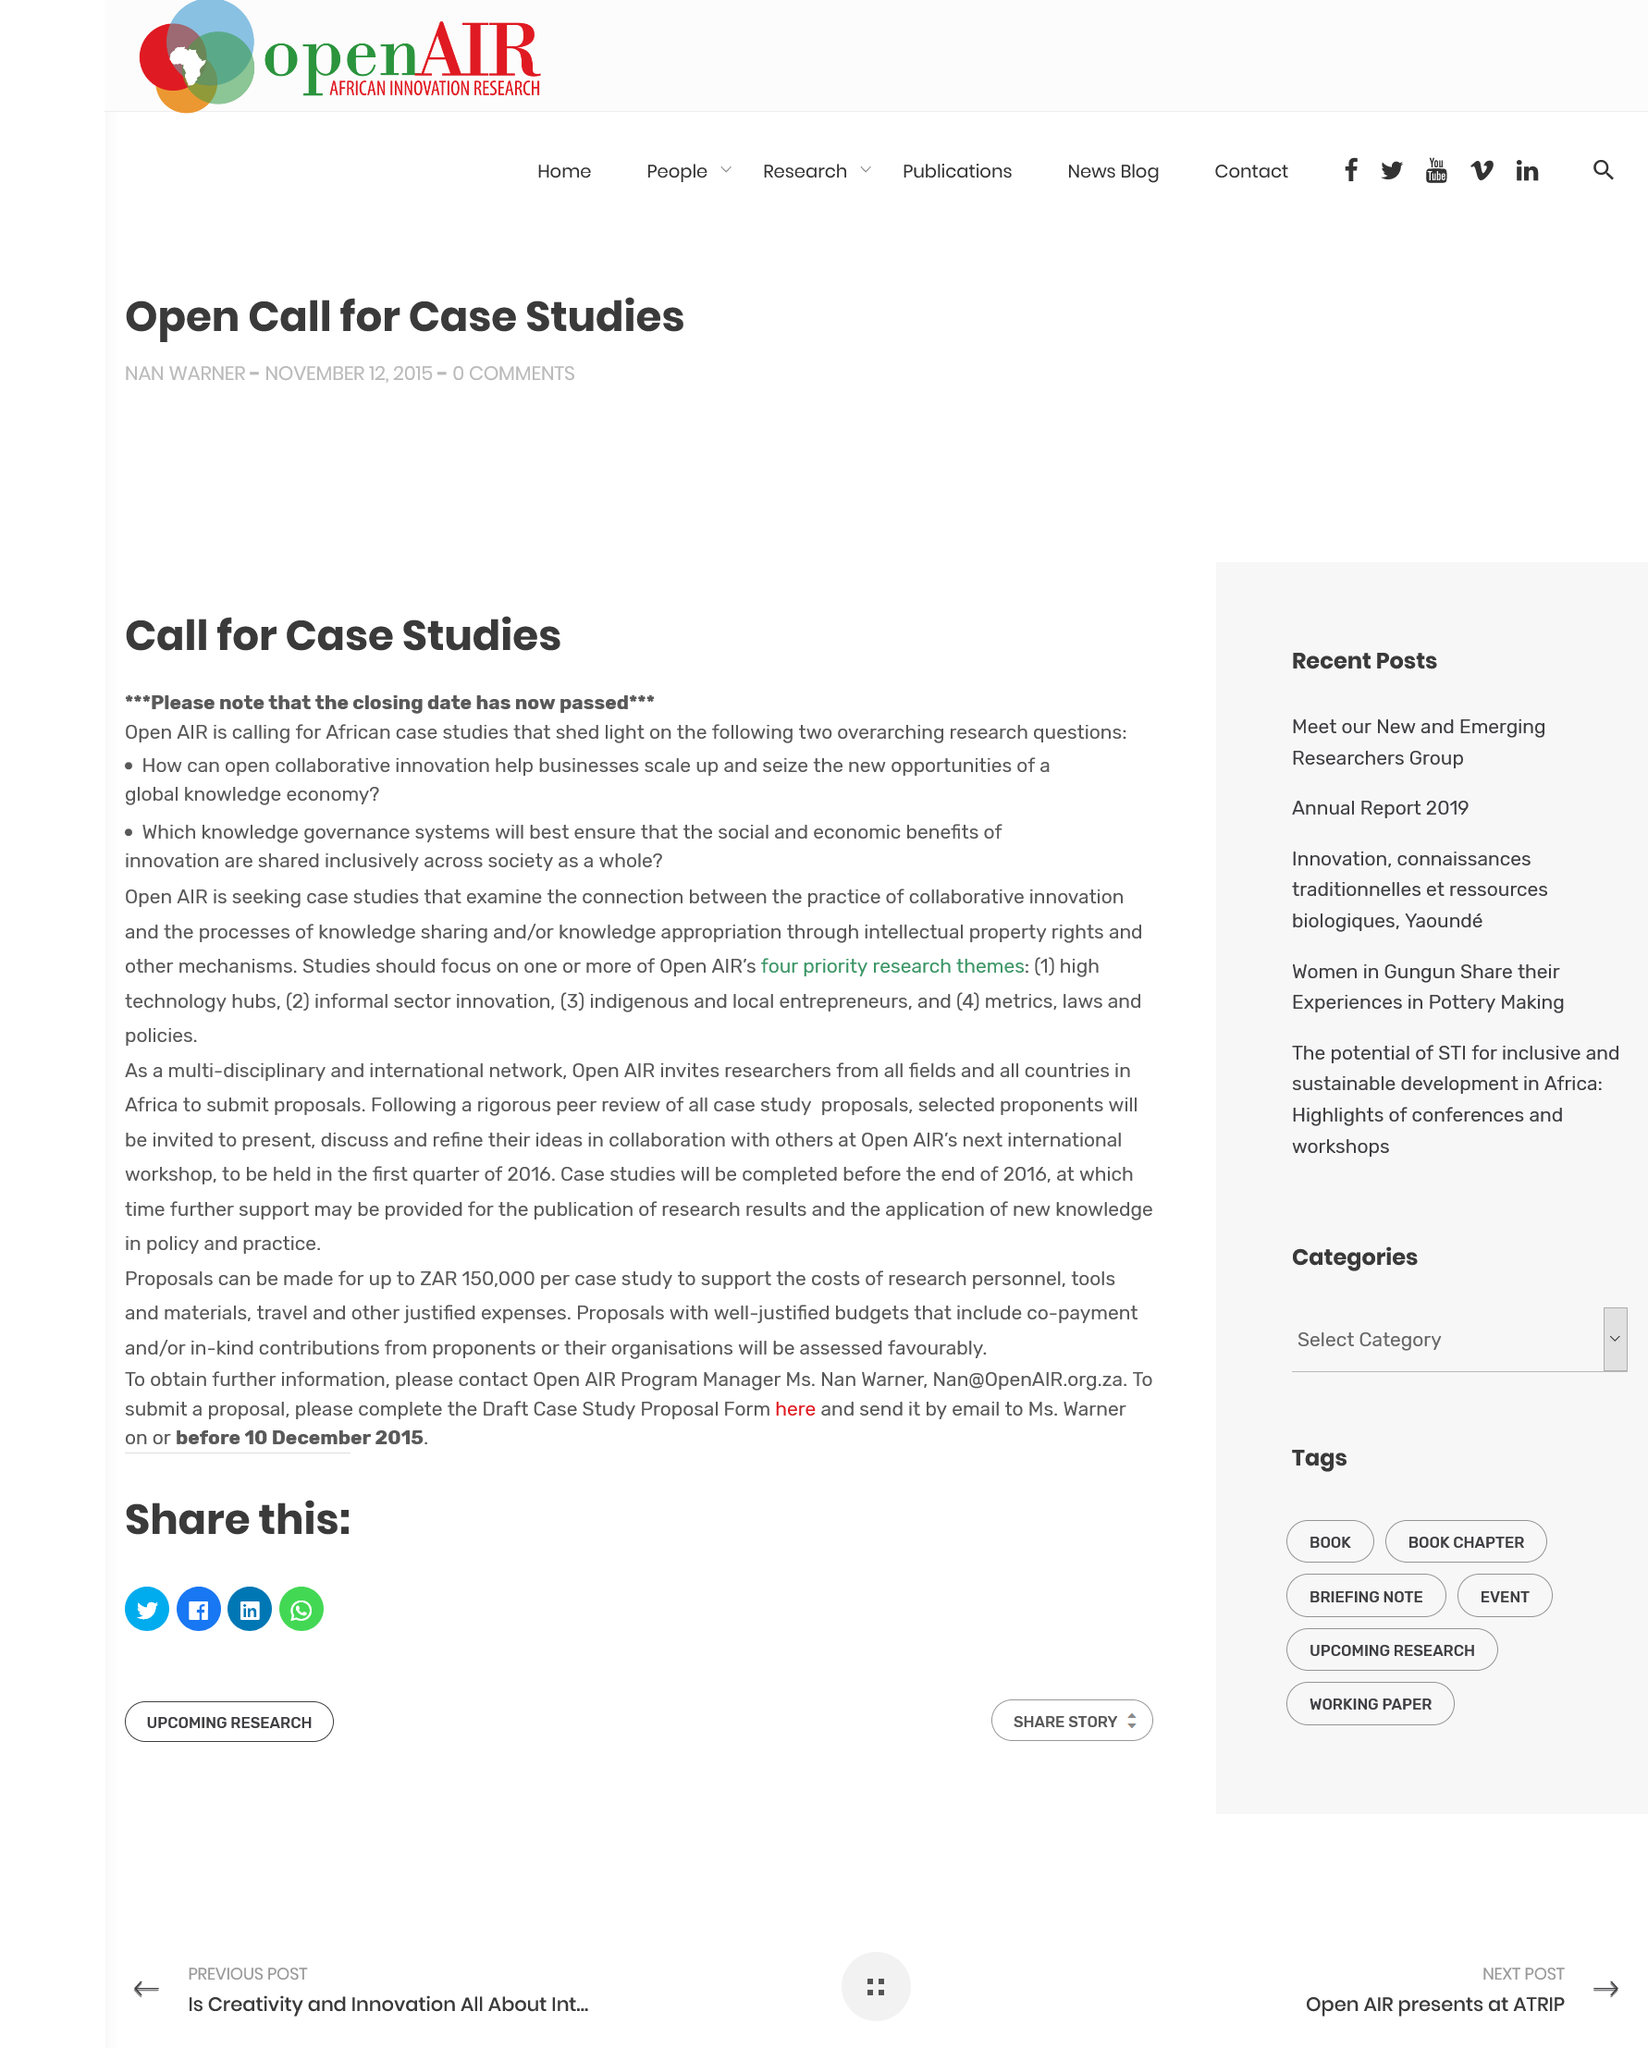Point out several critical features in this image. Open AIR is calling for African case studies that involve a particular type of situation or problem. This article is calling for case studies to be conducted and analyzed to better understand a given topic. 